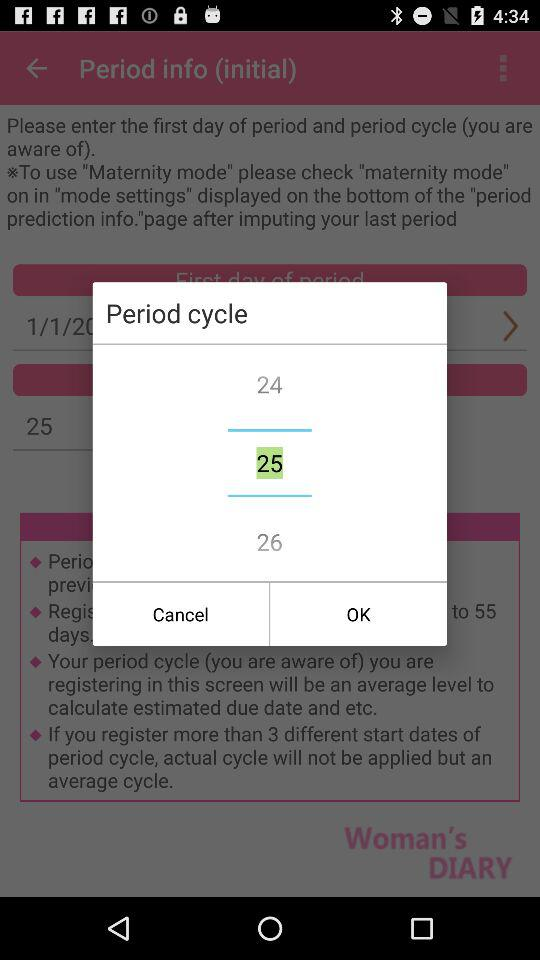How many numbers are displayed in the period cycle field?
Answer the question using a single word or phrase. 3 